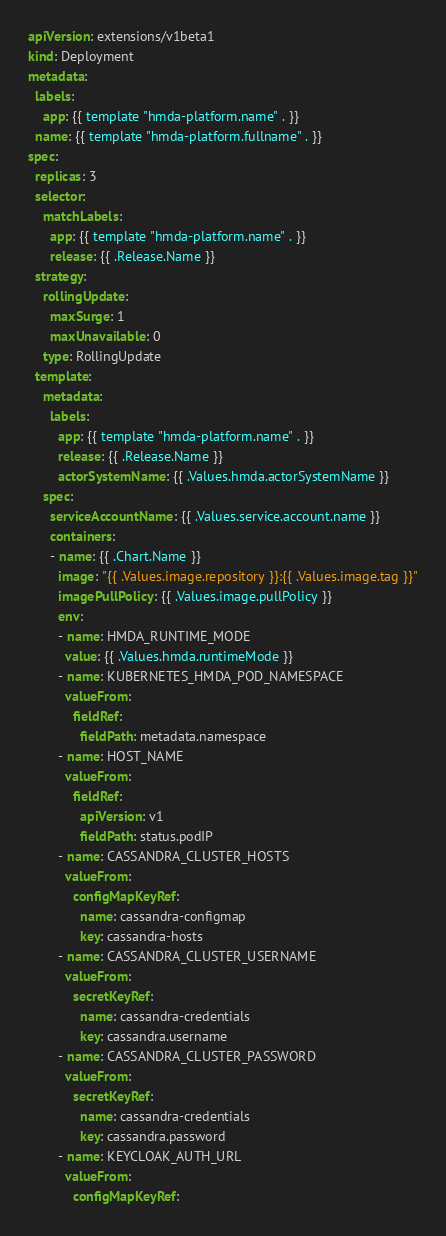<code> <loc_0><loc_0><loc_500><loc_500><_YAML_>apiVersion: extensions/v1beta1
kind: Deployment
metadata:
  labels:
    app: {{ template "hmda-platform.name" . }}
  name: {{ template "hmda-platform.fullname" . }}
spec:
  replicas: 3
  selector:
    matchLabels:
      app: {{ template "hmda-platform.name" . }}
      release: {{ .Release.Name }}
  strategy:
    rollingUpdate:
      maxSurge: 1
      maxUnavailable: 0
    type: RollingUpdate
  template:
    metadata:
      labels:
        app: {{ template "hmda-platform.name" . }}
        release: {{ .Release.Name }}
        actorSystemName: {{ .Values.hmda.actorSystemName }}
    spec:
      serviceAccountName: {{ .Values.service.account.name }}
      containers:
      - name: {{ .Chart.Name }}
        image: "{{ .Values.image.repository }}:{{ .Values.image.tag }}"
        imagePullPolicy: {{ .Values.image.pullPolicy }}
        env:
        - name: HMDA_RUNTIME_MODE
          value: {{ .Values.hmda.runtimeMode }}
        - name: KUBERNETES_HMDA_POD_NAMESPACE
          valueFrom:
            fieldRef:
              fieldPath: metadata.namespace
        - name: HOST_NAME
          valueFrom:
            fieldRef:
              apiVersion: v1
              fieldPath: status.podIP
        - name: CASSANDRA_CLUSTER_HOSTS
          valueFrom:
            configMapKeyRef:
              name: cassandra-configmap
              key: cassandra-hosts
        - name: CASSANDRA_CLUSTER_USERNAME
          valueFrom:
            secretKeyRef:
              name: cassandra-credentials
              key: cassandra.username
        - name: CASSANDRA_CLUSTER_PASSWORD
          valueFrom:
            secretKeyRef:
              name: cassandra-credentials
              key: cassandra.password
        - name: KEYCLOAK_AUTH_URL
          valueFrom:
            configMapKeyRef:</code> 